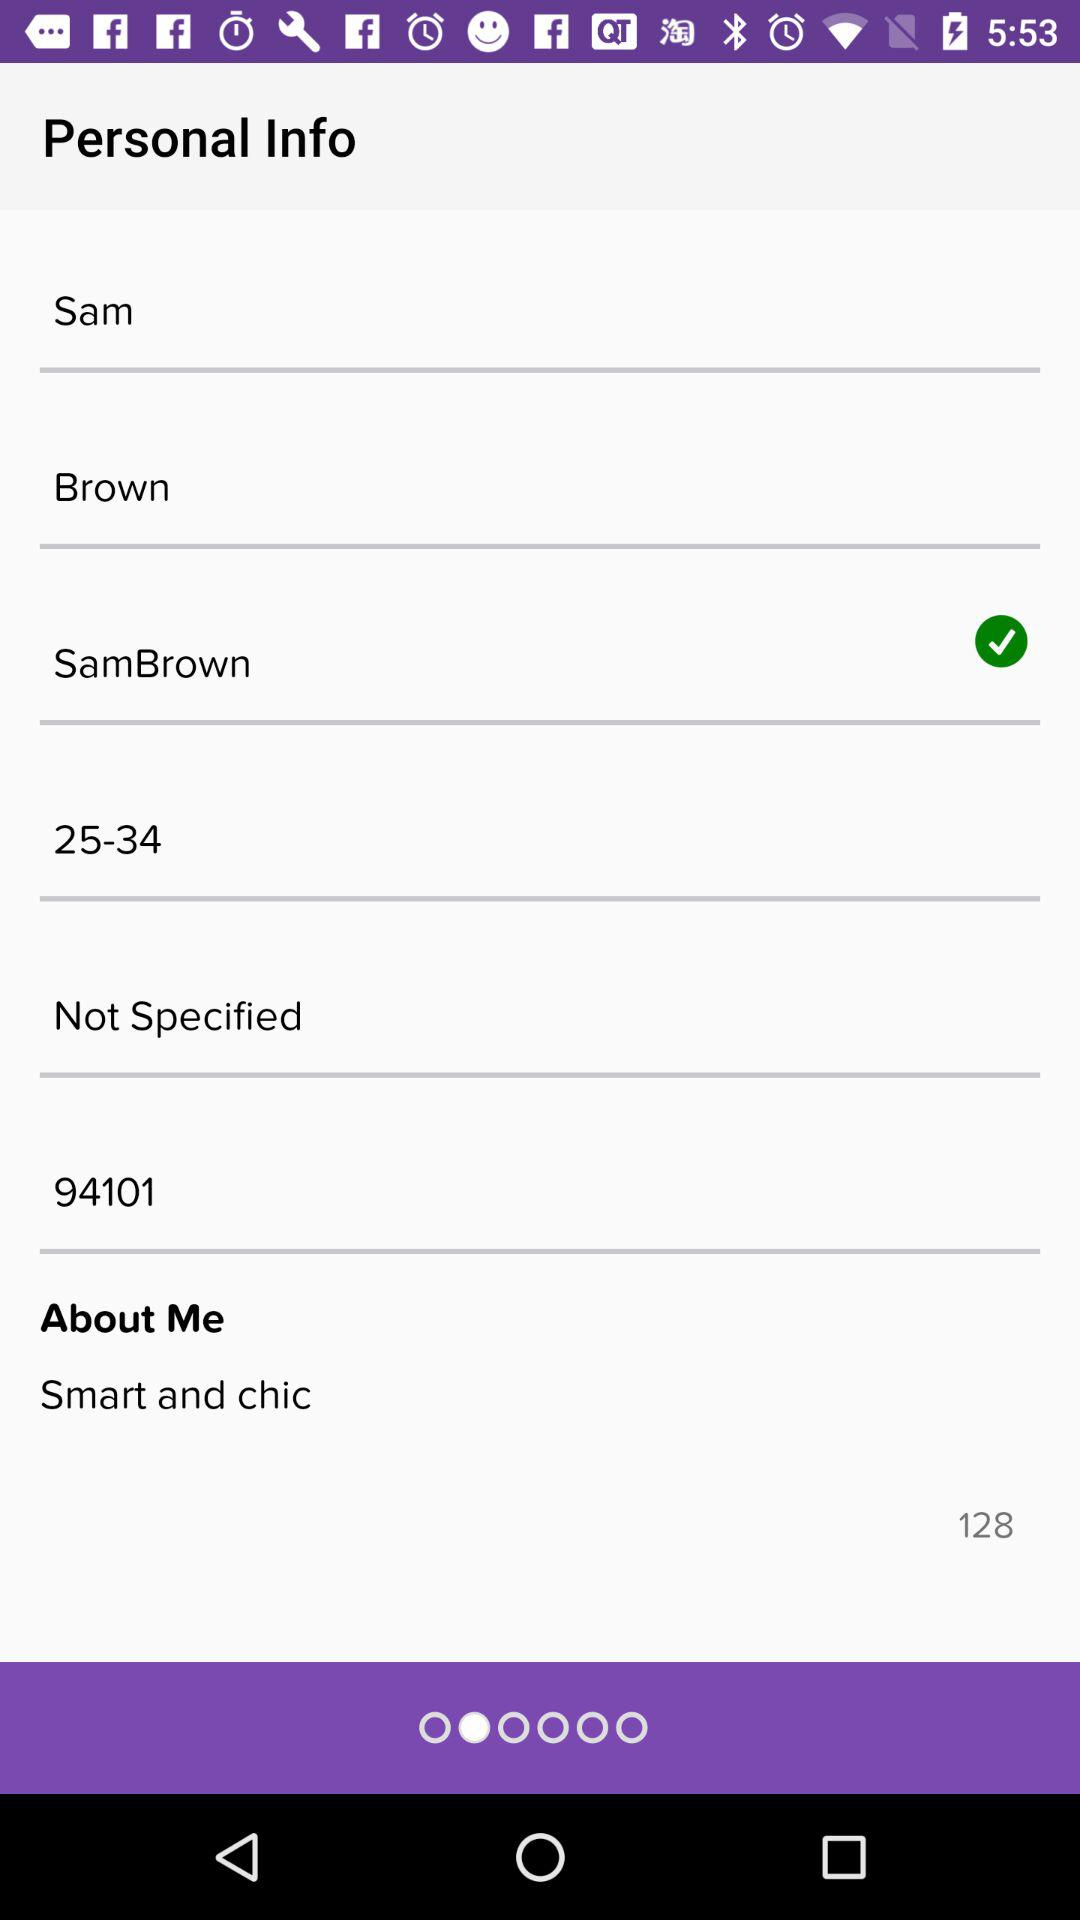How many characters are mentioned in the "About Me" section? There are 128 characters mentioned in the "About Me" section. 